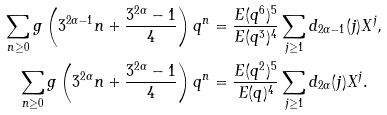Convert formula to latex. <formula><loc_0><loc_0><loc_500><loc_500>\sum _ { n \geq 0 } g \left ( 3 ^ { 2 \alpha - 1 } n + \frac { 3 ^ { 2 \alpha } - 1 } { 4 } \right ) q ^ { n } & = \frac { E ( q ^ { 6 } ) ^ { 5 } } { E ( q ^ { 3 } ) ^ { 4 } } \sum _ { j \geq 1 } d _ { 2 \alpha - 1 } ( j ) X ^ { j } , \\ \sum _ { n \geq 0 } g \left ( 3 ^ { 2 \alpha } n + \frac { 3 ^ { 2 \alpha } - 1 } { 4 } \right ) q ^ { n } & = \frac { E ( q ^ { 2 } ) ^ { 5 } } { E ( q ) ^ { 4 } } \sum _ { j \geq 1 } d _ { 2 \alpha } ( j ) X ^ { j } .</formula> 